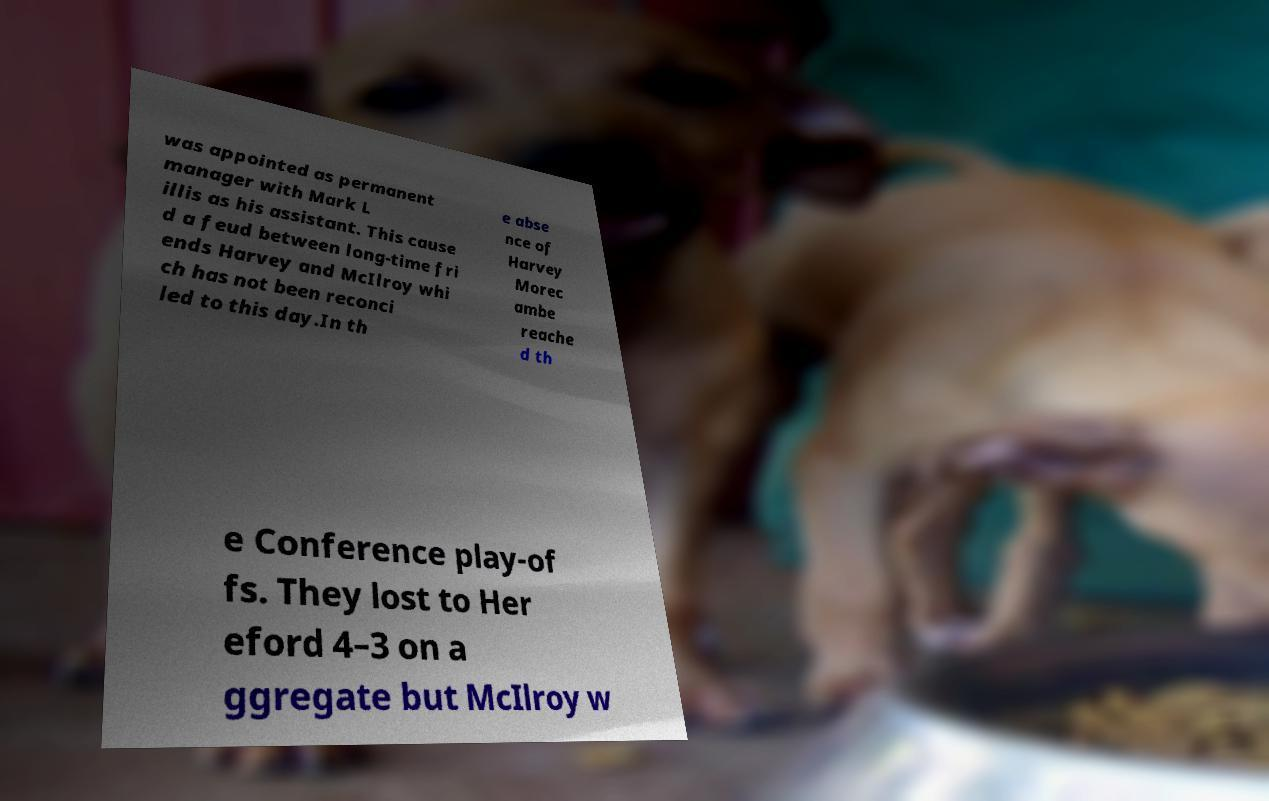There's text embedded in this image that I need extracted. Can you transcribe it verbatim? was appointed as permanent manager with Mark L illis as his assistant. This cause d a feud between long-time fri ends Harvey and McIlroy whi ch has not been reconci led to this day.In th e abse nce of Harvey Morec ambe reache d th e Conference play-of fs. They lost to Her eford 4–3 on a ggregate but McIlroy w 